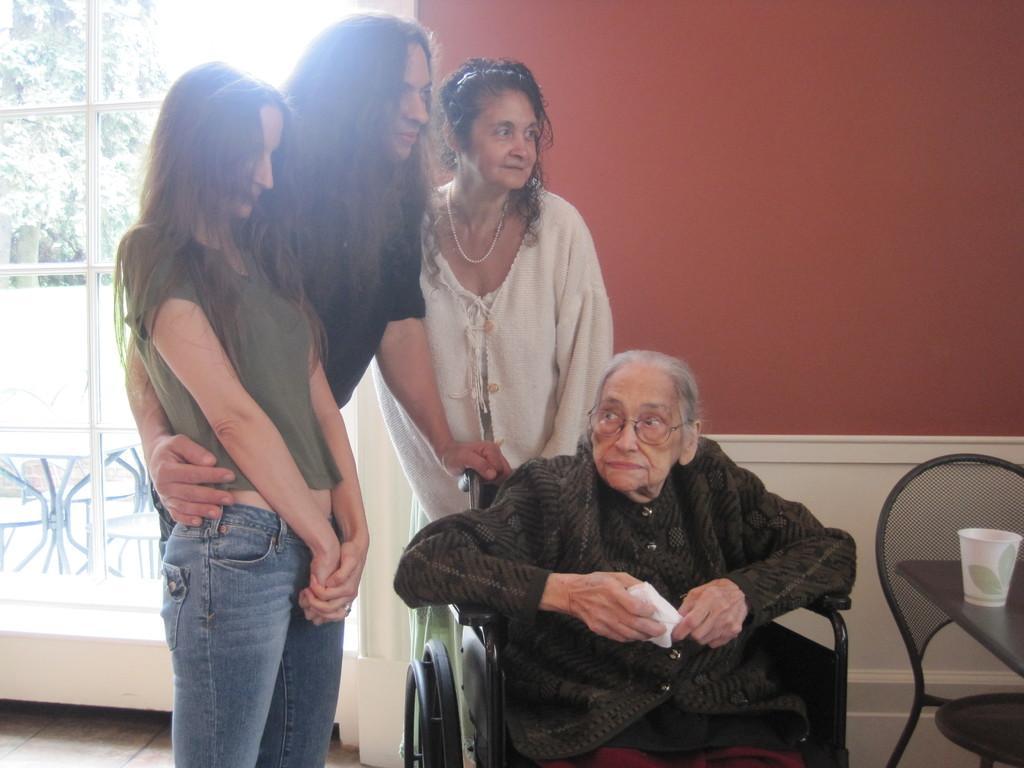Can you describe this image briefly? In this image there are four women's. Out of which three women's are standing and one person is sitting on the wheelchair. In front of that a table is there on which glass is kept. The background walls are red in color and white in color. And door visible, through visible trees are visible. This image is taken inside a house. 